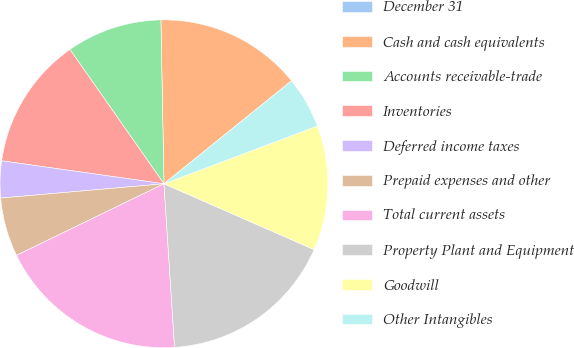<chart> <loc_0><loc_0><loc_500><loc_500><pie_chart><fcel>December 31<fcel>Cash and cash equivalents<fcel>Accounts receivable-trade<fcel>Inventories<fcel>Deferred income taxes<fcel>Prepaid expenses and other<fcel>Total current assets<fcel>Property Plant and Equipment<fcel>Goodwill<fcel>Other Intangibles<nl><fcel>0.0%<fcel>14.49%<fcel>9.42%<fcel>13.04%<fcel>3.63%<fcel>5.8%<fcel>18.84%<fcel>17.39%<fcel>12.32%<fcel>5.07%<nl></chart> 